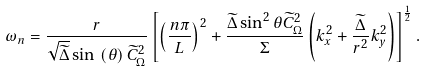Convert formula to latex. <formula><loc_0><loc_0><loc_500><loc_500>\omega _ { n } = \frac { r } { \sqrt { \widetilde { \Delta } } \sin \, \left ( \theta \right ) \widetilde { C } ^ { 2 } _ { \Omega } } \left [ \left ( \frac { n \pi } { L } \right ) ^ { 2 } + \frac { \widetilde { \Delta } \sin ^ { 2 } { \theta } \widetilde { C } ^ { 2 } _ { \Omega } } { \Sigma } \left ( k _ { x } ^ { 2 } + \frac { \widetilde { \Delta } } { r ^ { 2 } } k _ { y } ^ { 2 } \right ) \right ] ^ { \frac { 1 } { 2 } } .</formula> 